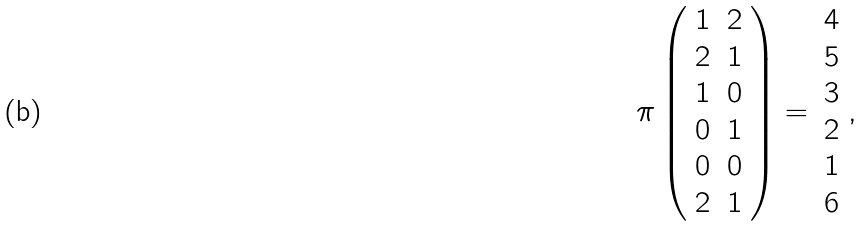<formula> <loc_0><loc_0><loc_500><loc_500>\pi \left ( \begin{array} { c c } 1 & 2 \\ 2 & 1 \\ 1 & 0 \\ 0 & 1 \\ 0 & 0 \\ 2 & 1 \end{array} \right ) = \begin{array} { c } 4 \\ 5 \\ 3 \\ 2 \\ 1 \\ 6 \end{array} ,</formula> 